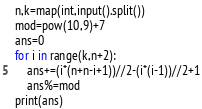<code> <loc_0><loc_0><loc_500><loc_500><_Python_>n,k=map(int,input().split())
mod=pow(10,9)+7
ans=0
for i in range(k,n+2):
    ans+=(i*(n+n-i+1))//2-(i*(i-1))//2+1
    ans%=mod
print(ans)</code> 